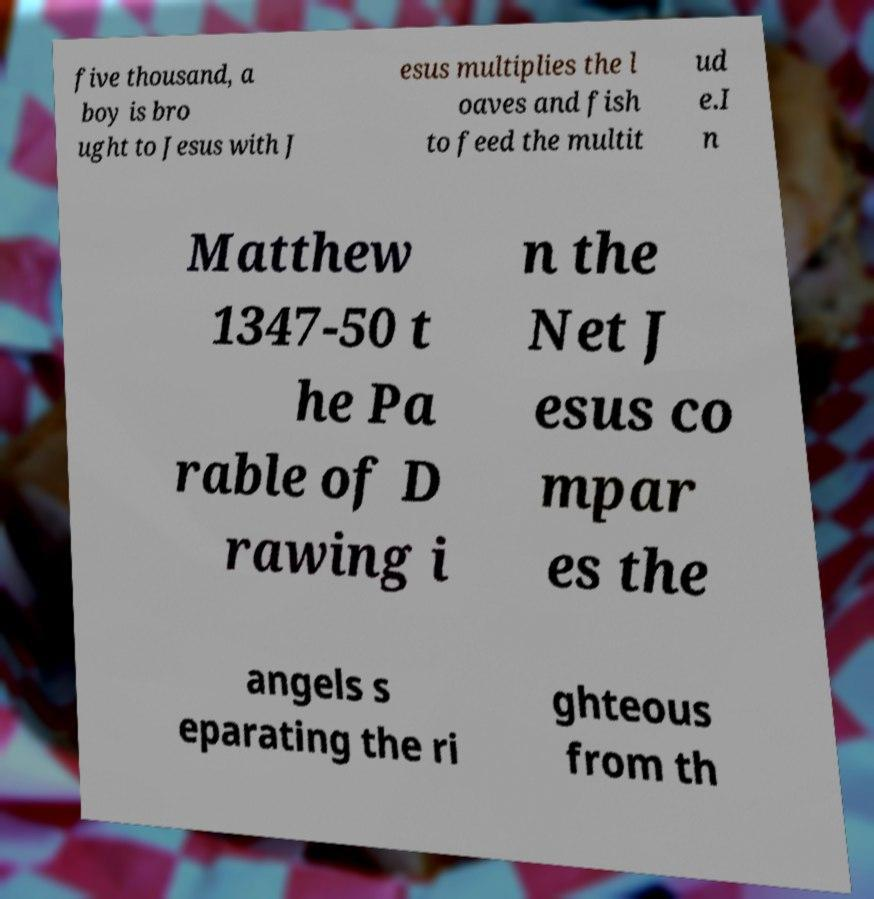Please identify and transcribe the text found in this image. five thousand, a boy is bro ught to Jesus with J esus multiplies the l oaves and fish to feed the multit ud e.I n Matthew 1347-50 t he Pa rable of D rawing i n the Net J esus co mpar es the angels s eparating the ri ghteous from th 